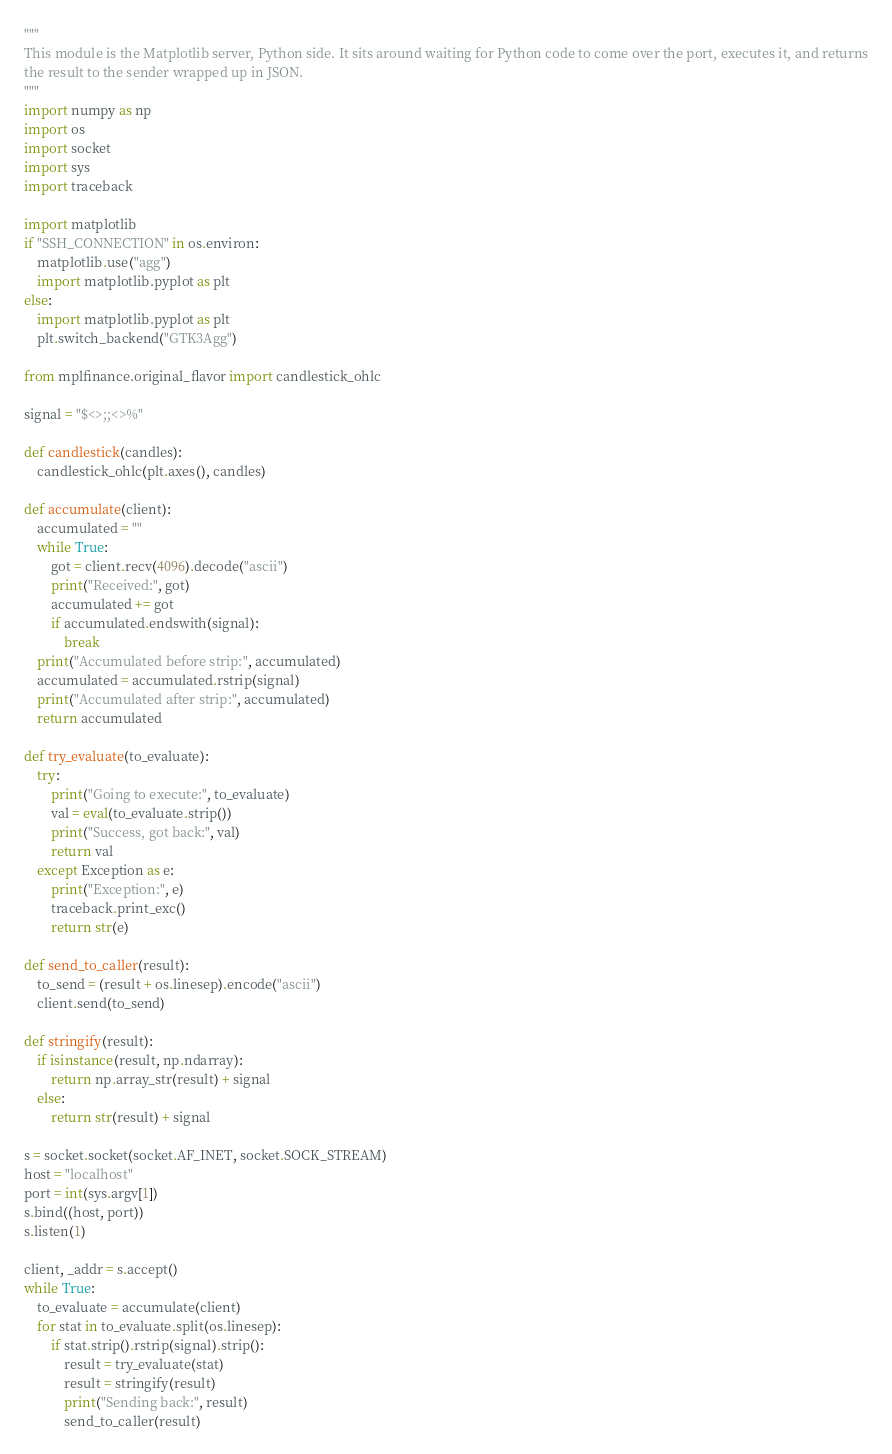Convert code to text. <code><loc_0><loc_0><loc_500><loc_500><_Python_>"""
This module is the Matplotlib server, Python side. It sits around waiting for Python code to come over the port, executes it, and returns
the result to the sender wrapped up in JSON.
"""
import numpy as np
import os
import socket
import sys
import traceback

import matplotlib
if "SSH_CONNECTION" in os.environ:
    matplotlib.use("agg")
    import matplotlib.pyplot as plt
else:
    import matplotlib.pyplot as plt
    plt.switch_backend("GTK3Agg")

from mplfinance.original_flavor import candlestick_ohlc

signal = "$<>;;<>%"

def candlestick(candles):
    candlestick_ohlc(plt.axes(), candles)

def accumulate(client):
    accumulated = ""
    while True:
        got = client.recv(4096).decode("ascii")
        print("Received:", got)
        accumulated += got
        if accumulated.endswith(signal):
            break
    print("Accumulated before strip:", accumulated)
    accumulated = accumulated.rstrip(signal)
    print("Accumulated after strip:", accumulated)
    return accumulated

def try_evaluate(to_evaluate):
    try:
        print("Going to execute:", to_evaluate)
        val = eval(to_evaluate.strip())
        print("Success, got back:", val)
        return val
    except Exception as e:
        print("Exception:", e)
        traceback.print_exc()
        return str(e)

def send_to_caller(result):
    to_send = (result + os.linesep).encode("ascii")
    client.send(to_send)

def stringify(result):
    if isinstance(result, np.ndarray):
        return np.array_str(result) + signal
    else:
        return str(result) + signal

s = socket.socket(socket.AF_INET, socket.SOCK_STREAM)
host = "localhost"
port = int(sys.argv[1])
s.bind((host, port))
s.listen(1)

client, _addr = s.accept()
while True:
    to_evaluate = accumulate(client)
    for stat in to_evaluate.split(os.linesep):
        if stat.strip().rstrip(signal).strip():
            result = try_evaluate(stat)
            result = stringify(result)
            print("Sending back:", result)
            send_to_caller(result)

</code> 